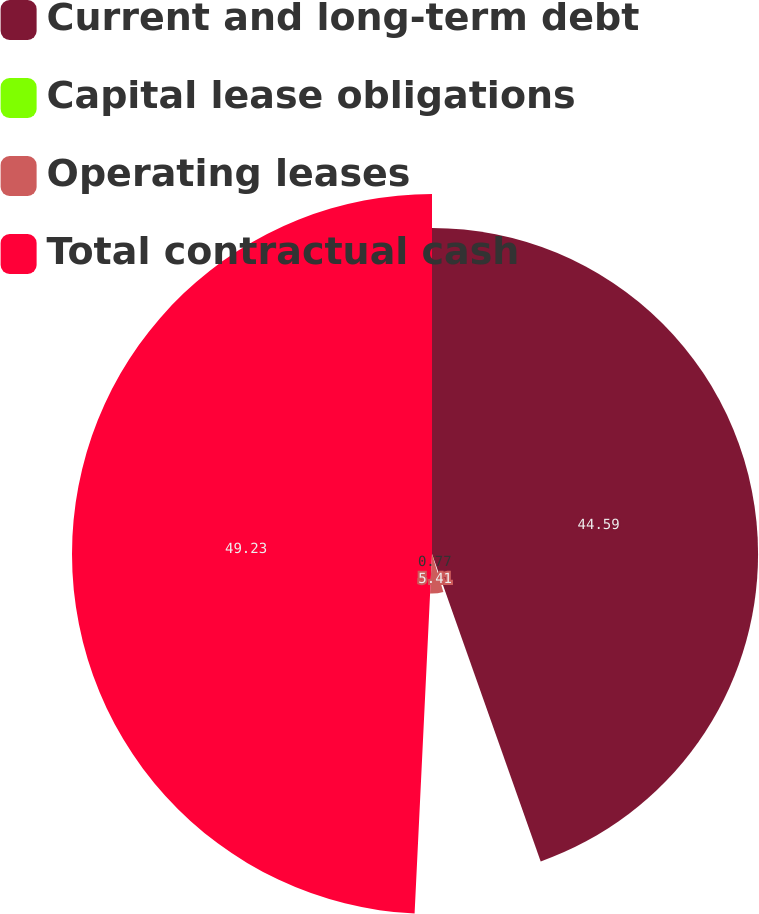Convert chart. <chart><loc_0><loc_0><loc_500><loc_500><pie_chart><fcel>Current and long-term debt<fcel>Capital lease obligations<fcel>Operating leases<fcel>Total contractual cash<nl><fcel>44.59%<fcel>0.77%<fcel>5.41%<fcel>49.23%<nl></chart> 